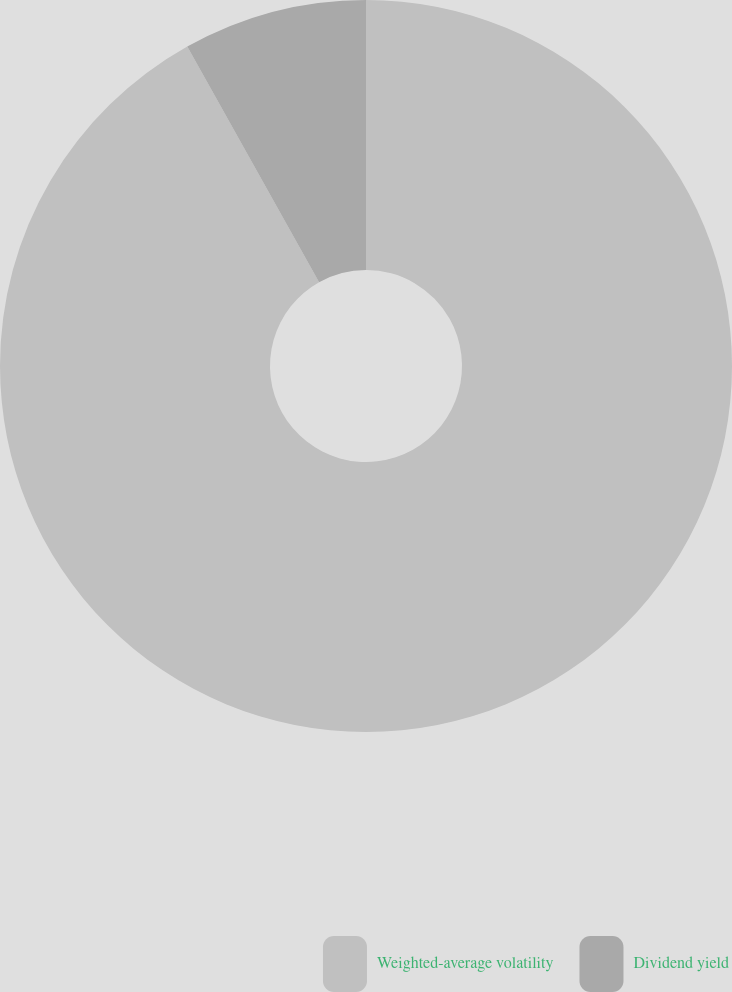Convert chart. <chart><loc_0><loc_0><loc_500><loc_500><pie_chart><fcel>Weighted-average volatility<fcel>Dividend yield<nl><fcel>91.88%<fcel>8.12%<nl></chart> 